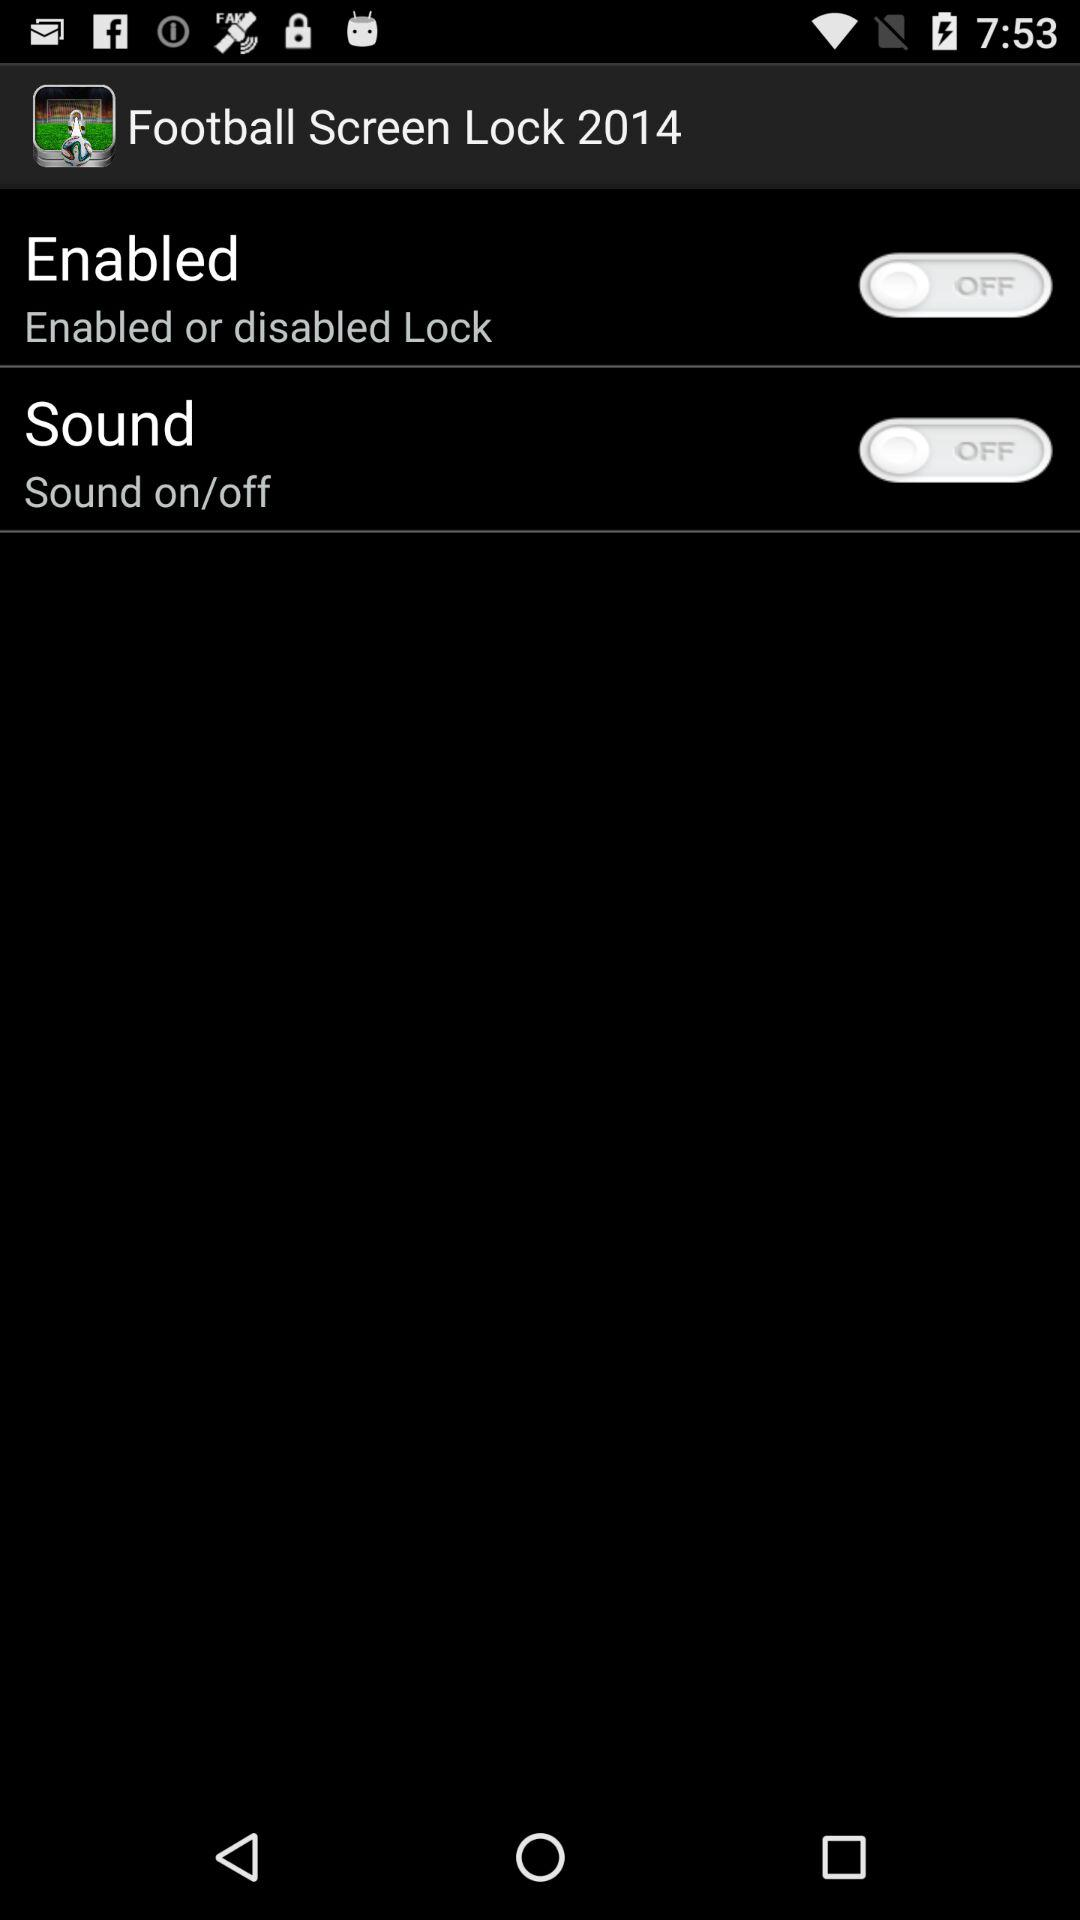Which team is selected?
When the provided information is insufficient, respond with <no answer>. <no answer> 